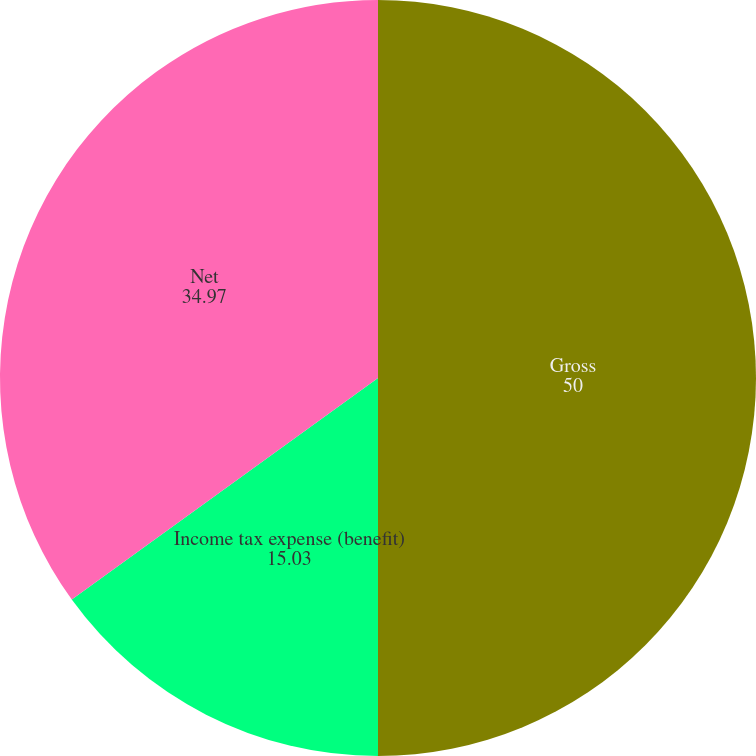Convert chart. <chart><loc_0><loc_0><loc_500><loc_500><pie_chart><fcel>Gross<fcel>Income tax expense (benefit)<fcel>Net<nl><fcel>50.0%<fcel>15.03%<fcel>34.97%<nl></chart> 